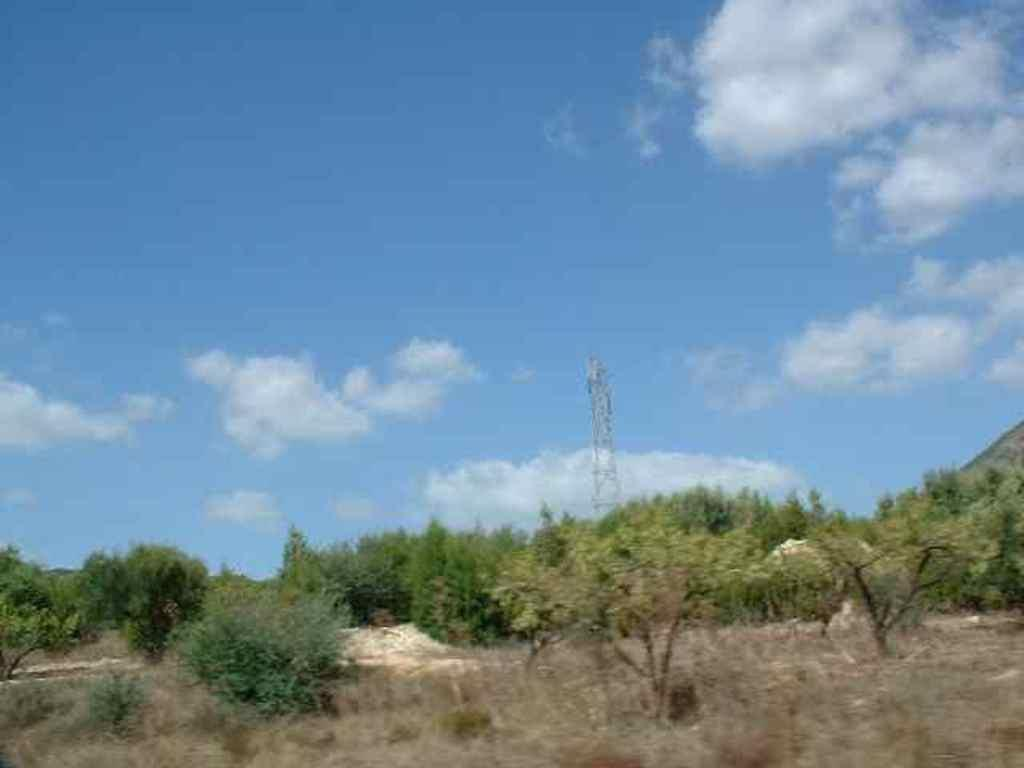What is the main object in the center of the image? There is a pole in the center of the image. What type of vegetation is present at the bottom of the image? There is dried grass on the floor at the bottom of the image. What else can be seen in the center of the image besides the pole? There are trees in the center of the image. Reasoning: Let' Let's think step by step in order to produce the conversation. We start by identifying the main object in the image, which is the pole. Then, we describe the vegetation present at the bottom of the image, which is dried grass. Finally, we mention the trees that are also present in the center of the image. Each question is designed to focus on a specific detail about the image that is known from the provided facts. Absurd Question/Answer: Where is the fireman in the image? There is no fireman present in the image. What type of bird can be seen perched on the pole in the image? There are no birds visible in the image, including wrens. 